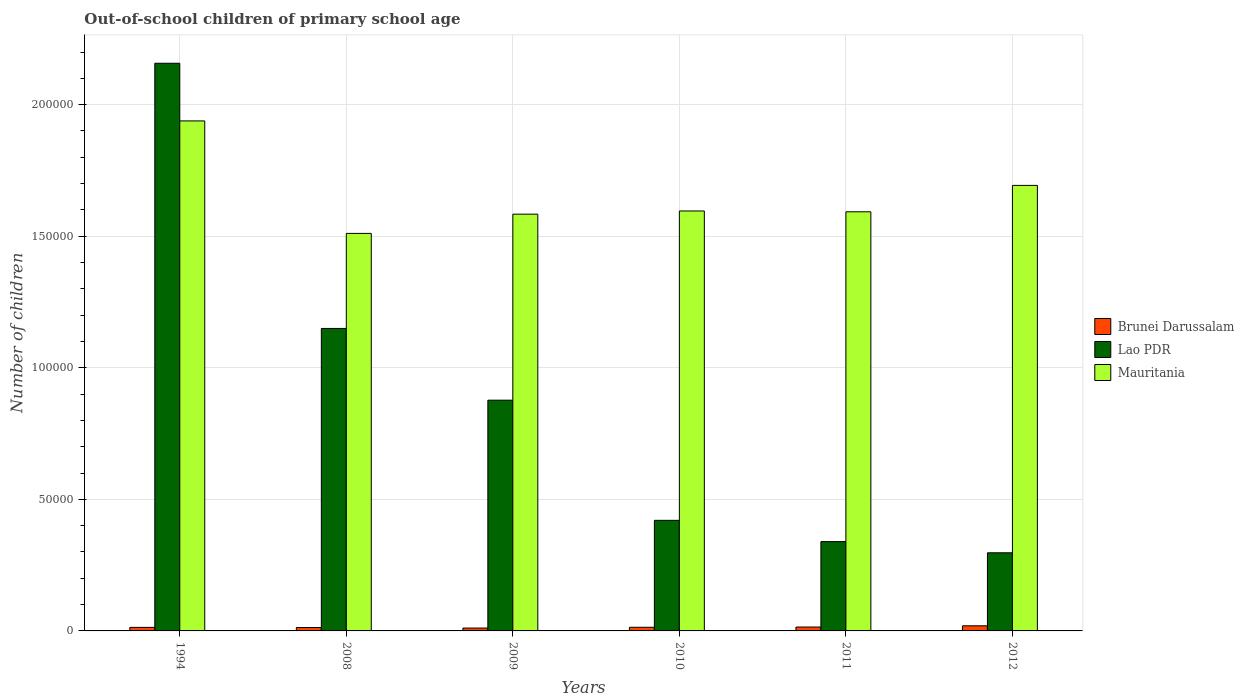How many different coloured bars are there?
Give a very brief answer. 3. Are the number of bars per tick equal to the number of legend labels?
Make the answer very short. Yes. Are the number of bars on each tick of the X-axis equal?
Provide a succinct answer. Yes. How many bars are there on the 6th tick from the left?
Your answer should be compact. 3. How many bars are there on the 1st tick from the right?
Give a very brief answer. 3. What is the label of the 4th group of bars from the left?
Offer a terse response. 2010. What is the number of out-of-school children in Mauritania in 2008?
Offer a very short reply. 1.51e+05. Across all years, what is the maximum number of out-of-school children in Lao PDR?
Make the answer very short. 2.16e+05. Across all years, what is the minimum number of out-of-school children in Brunei Darussalam?
Make the answer very short. 1092. In which year was the number of out-of-school children in Mauritania maximum?
Ensure brevity in your answer.  1994. What is the total number of out-of-school children in Lao PDR in the graph?
Your answer should be very brief. 5.24e+05. What is the difference between the number of out-of-school children in Brunei Darussalam in 2008 and that in 2012?
Your response must be concise. -651. What is the difference between the number of out-of-school children in Brunei Darussalam in 2009 and the number of out-of-school children in Mauritania in 1994?
Your response must be concise. -1.93e+05. What is the average number of out-of-school children in Lao PDR per year?
Ensure brevity in your answer.  8.73e+04. In the year 1994, what is the difference between the number of out-of-school children in Lao PDR and number of out-of-school children in Brunei Darussalam?
Give a very brief answer. 2.14e+05. What is the ratio of the number of out-of-school children in Mauritania in 2008 to that in 2009?
Provide a succinct answer. 0.95. Is the number of out-of-school children in Lao PDR in 1994 less than that in 2011?
Provide a short and direct response. No. What is the difference between the highest and the second highest number of out-of-school children in Lao PDR?
Ensure brevity in your answer.  1.01e+05. What is the difference between the highest and the lowest number of out-of-school children in Brunei Darussalam?
Offer a terse response. 852. In how many years, is the number of out-of-school children in Lao PDR greater than the average number of out-of-school children in Lao PDR taken over all years?
Provide a succinct answer. 3. Is the sum of the number of out-of-school children in Lao PDR in 1994 and 2008 greater than the maximum number of out-of-school children in Brunei Darussalam across all years?
Make the answer very short. Yes. What does the 2nd bar from the left in 2010 represents?
Provide a short and direct response. Lao PDR. What does the 2nd bar from the right in 2010 represents?
Provide a succinct answer. Lao PDR. How many bars are there?
Provide a succinct answer. 18. How many years are there in the graph?
Provide a short and direct response. 6. What is the difference between two consecutive major ticks on the Y-axis?
Make the answer very short. 5.00e+04. Are the values on the major ticks of Y-axis written in scientific E-notation?
Provide a short and direct response. No. Does the graph contain any zero values?
Your response must be concise. No. Does the graph contain grids?
Keep it short and to the point. Yes. Where does the legend appear in the graph?
Offer a very short reply. Center right. How many legend labels are there?
Give a very brief answer. 3. How are the legend labels stacked?
Give a very brief answer. Vertical. What is the title of the graph?
Your answer should be very brief. Out-of-school children of primary school age. What is the label or title of the Y-axis?
Ensure brevity in your answer.  Number of children. What is the Number of children in Brunei Darussalam in 1994?
Ensure brevity in your answer.  1342. What is the Number of children of Lao PDR in 1994?
Provide a succinct answer. 2.16e+05. What is the Number of children of Mauritania in 1994?
Make the answer very short. 1.94e+05. What is the Number of children in Brunei Darussalam in 2008?
Give a very brief answer. 1293. What is the Number of children in Lao PDR in 2008?
Make the answer very short. 1.15e+05. What is the Number of children of Mauritania in 2008?
Provide a short and direct response. 1.51e+05. What is the Number of children of Brunei Darussalam in 2009?
Ensure brevity in your answer.  1092. What is the Number of children of Lao PDR in 2009?
Make the answer very short. 8.77e+04. What is the Number of children of Mauritania in 2009?
Ensure brevity in your answer.  1.58e+05. What is the Number of children in Brunei Darussalam in 2010?
Provide a succinct answer. 1385. What is the Number of children in Lao PDR in 2010?
Provide a succinct answer. 4.20e+04. What is the Number of children of Mauritania in 2010?
Offer a very short reply. 1.60e+05. What is the Number of children in Brunei Darussalam in 2011?
Your answer should be compact. 1478. What is the Number of children of Lao PDR in 2011?
Give a very brief answer. 3.39e+04. What is the Number of children of Mauritania in 2011?
Ensure brevity in your answer.  1.59e+05. What is the Number of children of Brunei Darussalam in 2012?
Make the answer very short. 1944. What is the Number of children in Lao PDR in 2012?
Provide a succinct answer. 2.97e+04. What is the Number of children of Mauritania in 2012?
Provide a succinct answer. 1.69e+05. Across all years, what is the maximum Number of children in Brunei Darussalam?
Your answer should be very brief. 1944. Across all years, what is the maximum Number of children of Lao PDR?
Make the answer very short. 2.16e+05. Across all years, what is the maximum Number of children of Mauritania?
Your answer should be very brief. 1.94e+05. Across all years, what is the minimum Number of children of Brunei Darussalam?
Offer a terse response. 1092. Across all years, what is the minimum Number of children in Lao PDR?
Make the answer very short. 2.97e+04. Across all years, what is the minimum Number of children in Mauritania?
Your answer should be very brief. 1.51e+05. What is the total Number of children of Brunei Darussalam in the graph?
Make the answer very short. 8534. What is the total Number of children in Lao PDR in the graph?
Provide a short and direct response. 5.24e+05. What is the total Number of children in Mauritania in the graph?
Offer a very short reply. 9.91e+05. What is the difference between the Number of children of Lao PDR in 1994 and that in 2008?
Your answer should be compact. 1.01e+05. What is the difference between the Number of children of Mauritania in 1994 and that in 2008?
Provide a short and direct response. 4.27e+04. What is the difference between the Number of children in Brunei Darussalam in 1994 and that in 2009?
Your answer should be compact. 250. What is the difference between the Number of children in Lao PDR in 1994 and that in 2009?
Provide a succinct answer. 1.28e+05. What is the difference between the Number of children of Mauritania in 1994 and that in 2009?
Your answer should be very brief. 3.54e+04. What is the difference between the Number of children of Brunei Darussalam in 1994 and that in 2010?
Your answer should be compact. -43. What is the difference between the Number of children in Lao PDR in 1994 and that in 2010?
Provide a short and direct response. 1.74e+05. What is the difference between the Number of children of Mauritania in 1994 and that in 2010?
Your response must be concise. 3.42e+04. What is the difference between the Number of children in Brunei Darussalam in 1994 and that in 2011?
Provide a succinct answer. -136. What is the difference between the Number of children of Lao PDR in 1994 and that in 2011?
Provide a short and direct response. 1.82e+05. What is the difference between the Number of children in Mauritania in 1994 and that in 2011?
Make the answer very short. 3.45e+04. What is the difference between the Number of children in Brunei Darussalam in 1994 and that in 2012?
Your answer should be very brief. -602. What is the difference between the Number of children in Lao PDR in 1994 and that in 2012?
Provide a short and direct response. 1.86e+05. What is the difference between the Number of children of Mauritania in 1994 and that in 2012?
Ensure brevity in your answer.  2.45e+04. What is the difference between the Number of children of Brunei Darussalam in 2008 and that in 2009?
Offer a terse response. 201. What is the difference between the Number of children in Lao PDR in 2008 and that in 2009?
Offer a terse response. 2.73e+04. What is the difference between the Number of children of Mauritania in 2008 and that in 2009?
Ensure brevity in your answer.  -7315. What is the difference between the Number of children in Brunei Darussalam in 2008 and that in 2010?
Ensure brevity in your answer.  -92. What is the difference between the Number of children of Lao PDR in 2008 and that in 2010?
Your response must be concise. 7.29e+04. What is the difference between the Number of children in Mauritania in 2008 and that in 2010?
Your answer should be compact. -8517. What is the difference between the Number of children in Brunei Darussalam in 2008 and that in 2011?
Ensure brevity in your answer.  -185. What is the difference between the Number of children of Lao PDR in 2008 and that in 2011?
Give a very brief answer. 8.10e+04. What is the difference between the Number of children in Mauritania in 2008 and that in 2011?
Offer a terse response. -8208. What is the difference between the Number of children of Brunei Darussalam in 2008 and that in 2012?
Offer a very short reply. -651. What is the difference between the Number of children of Lao PDR in 2008 and that in 2012?
Give a very brief answer. 8.53e+04. What is the difference between the Number of children of Mauritania in 2008 and that in 2012?
Give a very brief answer. -1.82e+04. What is the difference between the Number of children in Brunei Darussalam in 2009 and that in 2010?
Your response must be concise. -293. What is the difference between the Number of children of Lao PDR in 2009 and that in 2010?
Provide a short and direct response. 4.57e+04. What is the difference between the Number of children in Mauritania in 2009 and that in 2010?
Offer a very short reply. -1202. What is the difference between the Number of children of Brunei Darussalam in 2009 and that in 2011?
Offer a very short reply. -386. What is the difference between the Number of children of Lao PDR in 2009 and that in 2011?
Your response must be concise. 5.37e+04. What is the difference between the Number of children of Mauritania in 2009 and that in 2011?
Provide a succinct answer. -893. What is the difference between the Number of children of Brunei Darussalam in 2009 and that in 2012?
Give a very brief answer. -852. What is the difference between the Number of children in Lao PDR in 2009 and that in 2012?
Your answer should be compact. 5.80e+04. What is the difference between the Number of children in Mauritania in 2009 and that in 2012?
Offer a terse response. -1.09e+04. What is the difference between the Number of children in Brunei Darussalam in 2010 and that in 2011?
Give a very brief answer. -93. What is the difference between the Number of children in Lao PDR in 2010 and that in 2011?
Your answer should be very brief. 8078. What is the difference between the Number of children of Mauritania in 2010 and that in 2011?
Offer a very short reply. 309. What is the difference between the Number of children in Brunei Darussalam in 2010 and that in 2012?
Provide a succinct answer. -559. What is the difference between the Number of children in Lao PDR in 2010 and that in 2012?
Offer a very short reply. 1.23e+04. What is the difference between the Number of children in Mauritania in 2010 and that in 2012?
Keep it short and to the point. -9724. What is the difference between the Number of children in Brunei Darussalam in 2011 and that in 2012?
Your response must be concise. -466. What is the difference between the Number of children in Lao PDR in 2011 and that in 2012?
Your answer should be compact. 4252. What is the difference between the Number of children of Mauritania in 2011 and that in 2012?
Give a very brief answer. -1.00e+04. What is the difference between the Number of children in Brunei Darussalam in 1994 and the Number of children in Lao PDR in 2008?
Give a very brief answer. -1.14e+05. What is the difference between the Number of children in Brunei Darussalam in 1994 and the Number of children in Mauritania in 2008?
Provide a short and direct response. -1.50e+05. What is the difference between the Number of children in Lao PDR in 1994 and the Number of children in Mauritania in 2008?
Make the answer very short. 6.47e+04. What is the difference between the Number of children in Brunei Darussalam in 1994 and the Number of children in Lao PDR in 2009?
Provide a succinct answer. -8.63e+04. What is the difference between the Number of children of Brunei Darussalam in 1994 and the Number of children of Mauritania in 2009?
Give a very brief answer. -1.57e+05. What is the difference between the Number of children in Lao PDR in 1994 and the Number of children in Mauritania in 2009?
Offer a terse response. 5.73e+04. What is the difference between the Number of children of Brunei Darussalam in 1994 and the Number of children of Lao PDR in 2010?
Give a very brief answer. -4.07e+04. What is the difference between the Number of children of Brunei Darussalam in 1994 and the Number of children of Mauritania in 2010?
Keep it short and to the point. -1.58e+05. What is the difference between the Number of children of Lao PDR in 1994 and the Number of children of Mauritania in 2010?
Your answer should be very brief. 5.61e+04. What is the difference between the Number of children of Brunei Darussalam in 1994 and the Number of children of Lao PDR in 2011?
Provide a short and direct response. -3.26e+04. What is the difference between the Number of children in Brunei Darussalam in 1994 and the Number of children in Mauritania in 2011?
Offer a terse response. -1.58e+05. What is the difference between the Number of children in Lao PDR in 1994 and the Number of children in Mauritania in 2011?
Ensure brevity in your answer.  5.64e+04. What is the difference between the Number of children in Brunei Darussalam in 1994 and the Number of children in Lao PDR in 2012?
Your answer should be compact. -2.84e+04. What is the difference between the Number of children in Brunei Darussalam in 1994 and the Number of children in Mauritania in 2012?
Your answer should be compact. -1.68e+05. What is the difference between the Number of children of Lao PDR in 1994 and the Number of children of Mauritania in 2012?
Offer a very short reply. 4.64e+04. What is the difference between the Number of children in Brunei Darussalam in 2008 and the Number of children in Lao PDR in 2009?
Give a very brief answer. -8.64e+04. What is the difference between the Number of children of Brunei Darussalam in 2008 and the Number of children of Mauritania in 2009?
Keep it short and to the point. -1.57e+05. What is the difference between the Number of children in Lao PDR in 2008 and the Number of children in Mauritania in 2009?
Give a very brief answer. -4.34e+04. What is the difference between the Number of children of Brunei Darussalam in 2008 and the Number of children of Lao PDR in 2010?
Keep it short and to the point. -4.07e+04. What is the difference between the Number of children in Brunei Darussalam in 2008 and the Number of children in Mauritania in 2010?
Offer a very short reply. -1.58e+05. What is the difference between the Number of children in Lao PDR in 2008 and the Number of children in Mauritania in 2010?
Your answer should be compact. -4.46e+04. What is the difference between the Number of children in Brunei Darussalam in 2008 and the Number of children in Lao PDR in 2011?
Offer a terse response. -3.27e+04. What is the difference between the Number of children in Brunei Darussalam in 2008 and the Number of children in Mauritania in 2011?
Ensure brevity in your answer.  -1.58e+05. What is the difference between the Number of children of Lao PDR in 2008 and the Number of children of Mauritania in 2011?
Your answer should be compact. -4.43e+04. What is the difference between the Number of children of Brunei Darussalam in 2008 and the Number of children of Lao PDR in 2012?
Give a very brief answer. -2.84e+04. What is the difference between the Number of children of Brunei Darussalam in 2008 and the Number of children of Mauritania in 2012?
Give a very brief answer. -1.68e+05. What is the difference between the Number of children of Lao PDR in 2008 and the Number of children of Mauritania in 2012?
Your answer should be compact. -5.44e+04. What is the difference between the Number of children of Brunei Darussalam in 2009 and the Number of children of Lao PDR in 2010?
Your response must be concise. -4.09e+04. What is the difference between the Number of children of Brunei Darussalam in 2009 and the Number of children of Mauritania in 2010?
Give a very brief answer. -1.58e+05. What is the difference between the Number of children in Lao PDR in 2009 and the Number of children in Mauritania in 2010?
Your response must be concise. -7.19e+04. What is the difference between the Number of children in Brunei Darussalam in 2009 and the Number of children in Lao PDR in 2011?
Your answer should be compact. -3.29e+04. What is the difference between the Number of children of Brunei Darussalam in 2009 and the Number of children of Mauritania in 2011?
Give a very brief answer. -1.58e+05. What is the difference between the Number of children in Lao PDR in 2009 and the Number of children in Mauritania in 2011?
Your answer should be very brief. -7.16e+04. What is the difference between the Number of children in Brunei Darussalam in 2009 and the Number of children in Lao PDR in 2012?
Offer a very short reply. -2.86e+04. What is the difference between the Number of children of Brunei Darussalam in 2009 and the Number of children of Mauritania in 2012?
Your response must be concise. -1.68e+05. What is the difference between the Number of children in Lao PDR in 2009 and the Number of children in Mauritania in 2012?
Offer a terse response. -8.16e+04. What is the difference between the Number of children in Brunei Darussalam in 2010 and the Number of children in Lao PDR in 2011?
Provide a short and direct response. -3.26e+04. What is the difference between the Number of children in Brunei Darussalam in 2010 and the Number of children in Mauritania in 2011?
Make the answer very short. -1.58e+05. What is the difference between the Number of children of Lao PDR in 2010 and the Number of children of Mauritania in 2011?
Your answer should be compact. -1.17e+05. What is the difference between the Number of children in Brunei Darussalam in 2010 and the Number of children in Lao PDR in 2012?
Keep it short and to the point. -2.83e+04. What is the difference between the Number of children of Brunei Darussalam in 2010 and the Number of children of Mauritania in 2012?
Offer a very short reply. -1.68e+05. What is the difference between the Number of children of Lao PDR in 2010 and the Number of children of Mauritania in 2012?
Your response must be concise. -1.27e+05. What is the difference between the Number of children of Brunei Darussalam in 2011 and the Number of children of Lao PDR in 2012?
Offer a terse response. -2.82e+04. What is the difference between the Number of children of Brunei Darussalam in 2011 and the Number of children of Mauritania in 2012?
Provide a short and direct response. -1.68e+05. What is the difference between the Number of children of Lao PDR in 2011 and the Number of children of Mauritania in 2012?
Your answer should be very brief. -1.35e+05. What is the average Number of children of Brunei Darussalam per year?
Offer a very short reply. 1422.33. What is the average Number of children of Lao PDR per year?
Your answer should be compact. 8.73e+04. What is the average Number of children in Mauritania per year?
Keep it short and to the point. 1.65e+05. In the year 1994, what is the difference between the Number of children in Brunei Darussalam and Number of children in Lao PDR?
Your response must be concise. -2.14e+05. In the year 1994, what is the difference between the Number of children of Brunei Darussalam and Number of children of Mauritania?
Offer a very short reply. -1.92e+05. In the year 1994, what is the difference between the Number of children in Lao PDR and Number of children in Mauritania?
Keep it short and to the point. 2.19e+04. In the year 2008, what is the difference between the Number of children in Brunei Darussalam and Number of children in Lao PDR?
Offer a terse response. -1.14e+05. In the year 2008, what is the difference between the Number of children in Brunei Darussalam and Number of children in Mauritania?
Give a very brief answer. -1.50e+05. In the year 2008, what is the difference between the Number of children of Lao PDR and Number of children of Mauritania?
Give a very brief answer. -3.61e+04. In the year 2009, what is the difference between the Number of children in Brunei Darussalam and Number of children in Lao PDR?
Your answer should be compact. -8.66e+04. In the year 2009, what is the difference between the Number of children in Brunei Darussalam and Number of children in Mauritania?
Keep it short and to the point. -1.57e+05. In the year 2009, what is the difference between the Number of children in Lao PDR and Number of children in Mauritania?
Ensure brevity in your answer.  -7.07e+04. In the year 2010, what is the difference between the Number of children in Brunei Darussalam and Number of children in Lao PDR?
Provide a succinct answer. -4.06e+04. In the year 2010, what is the difference between the Number of children in Brunei Darussalam and Number of children in Mauritania?
Your answer should be very brief. -1.58e+05. In the year 2010, what is the difference between the Number of children in Lao PDR and Number of children in Mauritania?
Provide a short and direct response. -1.18e+05. In the year 2011, what is the difference between the Number of children in Brunei Darussalam and Number of children in Lao PDR?
Your response must be concise. -3.25e+04. In the year 2011, what is the difference between the Number of children in Brunei Darussalam and Number of children in Mauritania?
Provide a succinct answer. -1.58e+05. In the year 2011, what is the difference between the Number of children of Lao PDR and Number of children of Mauritania?
Ensure brevity in your answer.  -1.25e+05. In the year 2012, what is the difference between the Number of children in Brunei Darussalam and Number of children in Lao PDR?
Provide a short and direct response. -2.78e+04. In the year 2012, what is the difference between the Number of children of Brunei Darussalam and Number of children of Mauritania?
Your response must be concise. -1.67e+05. In the year 2012, what is the difference between the Number of children in Lao PDR and Number of children in Mauritania?
Your answer should be compact. -1.40e+05. What is the ratio of the Number of children in Brunei Darussalam in 1994 to that in 2008?
Offer a very short reply. 1.04. What is the ratio of the Number of children of Lao PDR in 1994 to that in 2008?
Ensure brevity in your answer.  1.88. What is the ratio of the Number of children in Mauritania in 1994 to that in 2008?
Your response must be concise. 1.28. What is the ratio of the Number of children of Brunei Darussalam in 1994 to that in 2009?
Ensure brevity in your answer.  1.23. What is the ratio of the Number of children of Lao PDR in 1994 to that in 2009?
Your response must be concise. 2.46. What is the ratio of the Number of children in Mauritania in 1994 to that in 2009?
Offer a very short reply. 1.22. What is the ratio of the Number of children in Lao PDR in 1994 to that in 2010?
Provide a succinct answer. 5.13. What is the ratio of the Number of children of Mauritania in 1994 to that in 2010?
Your response must be concise. 1.21. What is the ratio of the Number of children in Brunei Darussalam in 1994 to that in 2011?
Keep it short and to the point. 0.91. What is the ratio of the Number of children of Lao PDR in 1994 to that in 2011?
Ensure brevity in your answer.  6.36. What is the ratio of the Number of children in Mauritania in 1994 to that in 2011?
Offer a terse response. 1.22. What is the ratio of the Number of children of Brunei Darussalam in 1994 to that in 2012?
Provide a short and direct response. 0.69. What is the ratio of the Number of children of Lao PDR in 1994 to that in 2012?
Give a very brief answer. 7.26. What is the ratio of the Number of children in Mauritania in 1994 to that in 2012?
Give a very brief answer. 1.14. What is the ratio of the Number of children of Brunei Darussalam in 2008 to that in 2009?
Give a very brief answer. 1.18. What is the ratio of the Number of children in Lao PDR in 2008 to that in 2009?
Give a very brief answer. 1.31. What is the ratio of the Number of children in Mauritania in 2008 to that in 2009?
Give a very brief answer. 0.95. What is the ratio of the Number of children of Brunei Darussalam in 2008 to that in 2010?
Make the answer very short. 0.93. What is the ratio of the Number of children in Lao PDR in 2008 to that in 2010?
Offer a terse response. 2.74. What is the ratio of the Number of children of Mauritania in 2008 to that in 2010?
Offer a very short reply. 0.95. What is the ratio of the Number of children of Brunei Darussalam in 2008 to that in 2011?
Give a very brief answer. 0.87. What is the ratio of the Number of children of Lao PDR in 2008 to that in 2011?
Give a very brief answer. 3.39. What is the ratio of the Number of children in Mauritania in 2008 to that in 2011?
Your answer should be very brief. 0.95. What is the ratio of the Number of children of Brunei Darussalam in 2008 to that in 2012?
Keep it short and to the point. 0.67. What is the ratio of the Number of children in Lao PDR in 2008 to that in 2012?
Your response must be concise. 3.87. What is the ratio of the Number of children in Mauritania in 2008 to that in 2012?
Your response must be concise. 0.89. What is the ratio of the Number of children in Brunei Darussalam in 2009 to that in 2010?
Give a very brief answer. 0.79. What is the ratio of the Number of children of Lao PDR in 2009 to that in 2010?
Provide a short and direct response. 2.09. What is the ratio of the Number of children in Mauritania in 2009 to that in 2010?
Your answer should be compact. 0.99. What is the ratio of the Number of children in Brunei Darussalam in 2009 to that in 2011?
Your answer should be compact. 0.74. What is the ratio of the Number of children of Lao PDR in 2009 to that in 2011?
Provide a short and direct response. 2.58. What is the ratio of the Number of children in Mauritania in 2009 to that in 2011?
Your answer should be compact. 0.99. What is the ratio of the Number of children in Brunei Darussalam in 2009 to that in 2012?
Provide a succinct answer. 0.56. What is the ratio of the Number of children of Lao PDR in 2009 to that in 2012?
Your answer should be very brief. 2.95. What is the ratio of the Number of children in Mauritania in 2009 to that in 2012?
Give a very brief answer. 0.94. What is the ratio of the Number of children in Brunei Darussalam in 2010 to that in 2011?
Provide a succinct answer. 0.94. What is the ratio of the Number of children of Lao PDR in 2010 to that in 2011?
Your response must be concise. 1.24. What is the ratio of the Number of children in Mauritania in 2010 to that in 2011?
Your response must be concise. 1. What is the ratio of the Number of children in Brunei Darussalam in 2010 to that in 2012?
Keep it short and to the point. 0.71. What is the ratio of the Number of children of Lao PDR in 2010 to that in 2012?
Ensure brevity in your answer.  1.42. What is the ratio of the Number of children in Mauritania in 2010 to that in 2012?
Offer a terse response. 0.94. What is the ratio of the Number of children of Brunei Darussalam in 2011 to that in 2012?
Give a very brief answer. 0.76. What is the ratio of the Number of children in Lao PDR in 2011 to that in 2012?
Your answer should be compact. 1.14. What is the ratio of the Number of children in Mauritania in 2011 to that in 2012?
Your answer should be very brief. 0.94. What is the difference between the highest and the second highest Number of children of Brunei Darussalam?
Provide a short and direct response. 466. What is the difference between the highest and the second highest Number of children of Lao PDR?
Make the answer very short. 1.01e+05. What is the difference between the highest and the second highest Number of children in Mauritania?
Your answer should be compact. 2.45e+04. What is the difference between the highest and the lowest Number of children in Brunei Darussalam?
Provide a succinct answer. 852. What is the difference between the highest and the lowest Number of children in Lao PDR?
Offer a very short reply. 1.86e+05. What is the difference between the highest and the lowest Number of children in Mauritania?
Your answer should be very brief. 4.27e+04. 